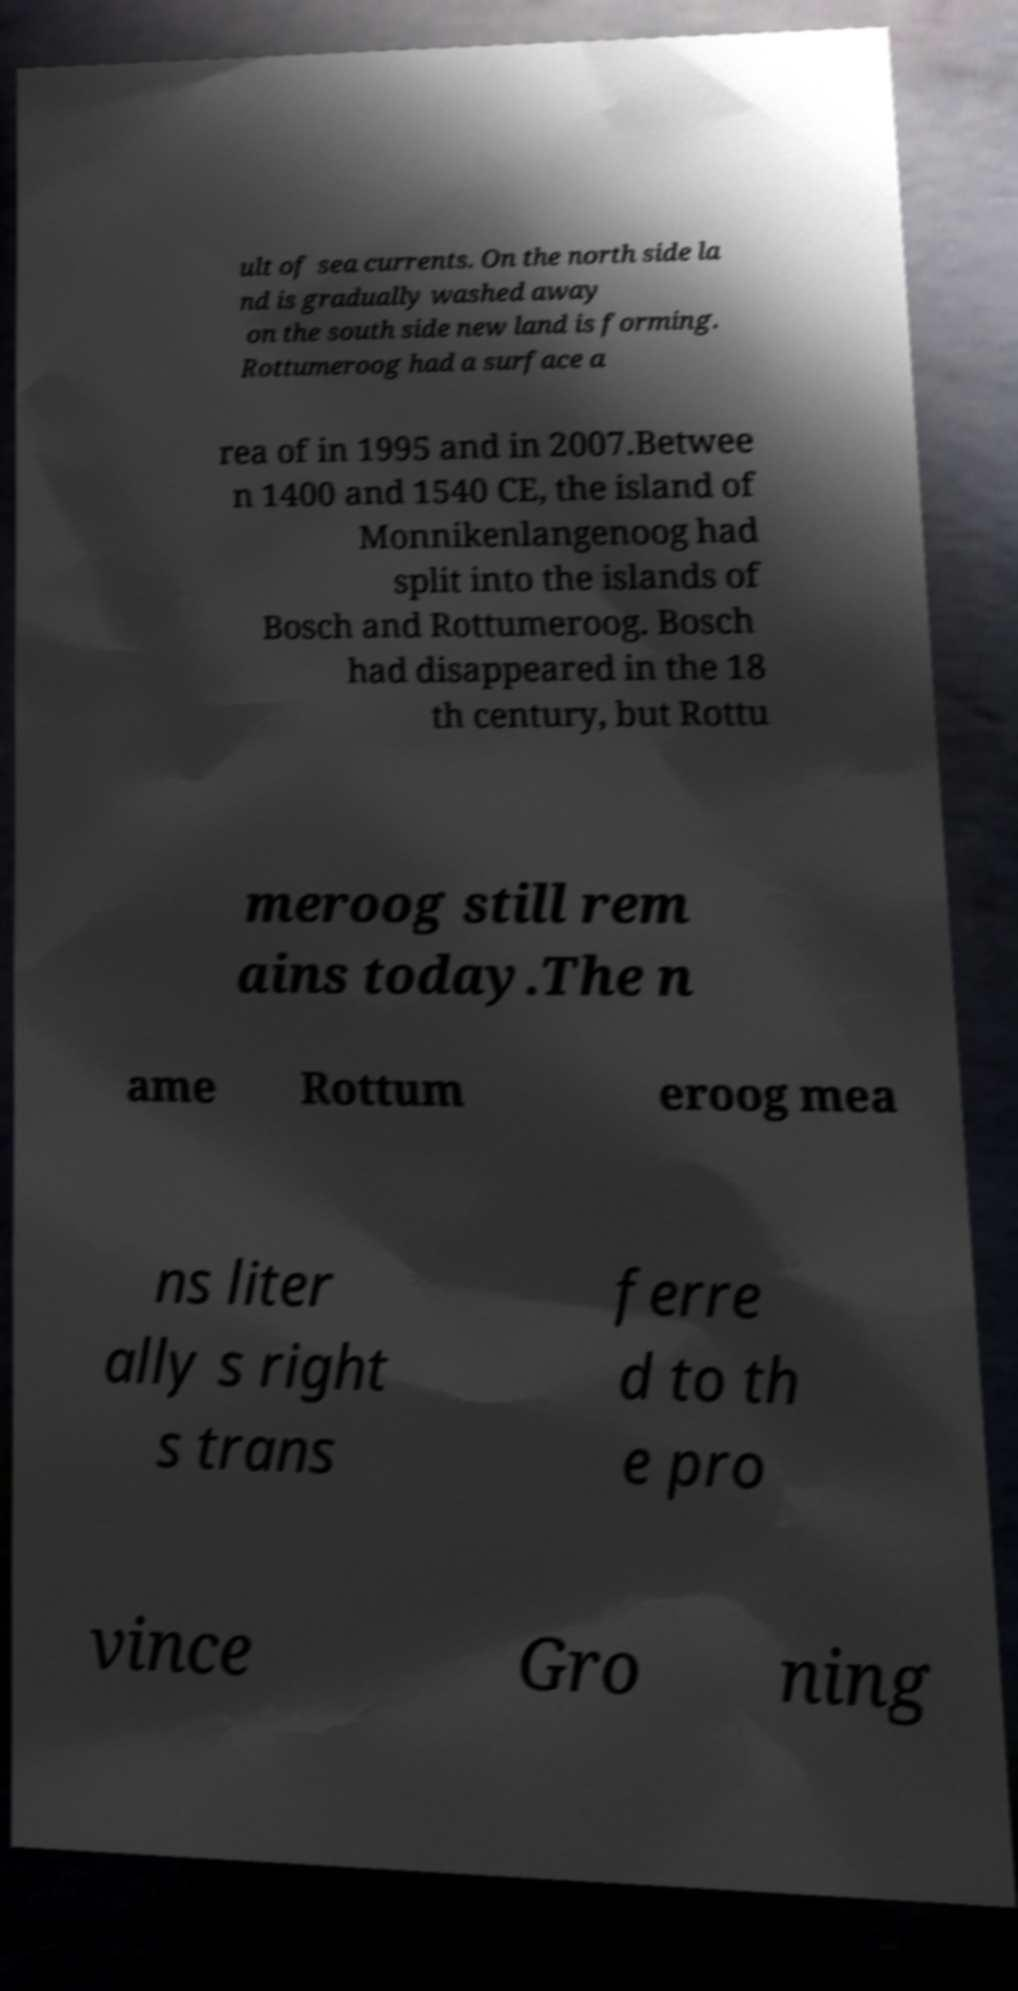Could you extract and type out the text from this image? ult of sea currents. On the north side la nd is gradually washed away on the south side new land is forming. Rottumeroog had a surface a rea of in 1995 and in 2007.Betwee n 1400 and 1540 CE, the island of Monnikenlangenoog had split into the islands of Bosch and Rottumeroog. Bosch had disappeared in the 18 th century, but Rottu meroog still rem ains today.The n ame Rottum eroog mea ns liter ally s right s trans ferre d to th e pro vince Gro ning 